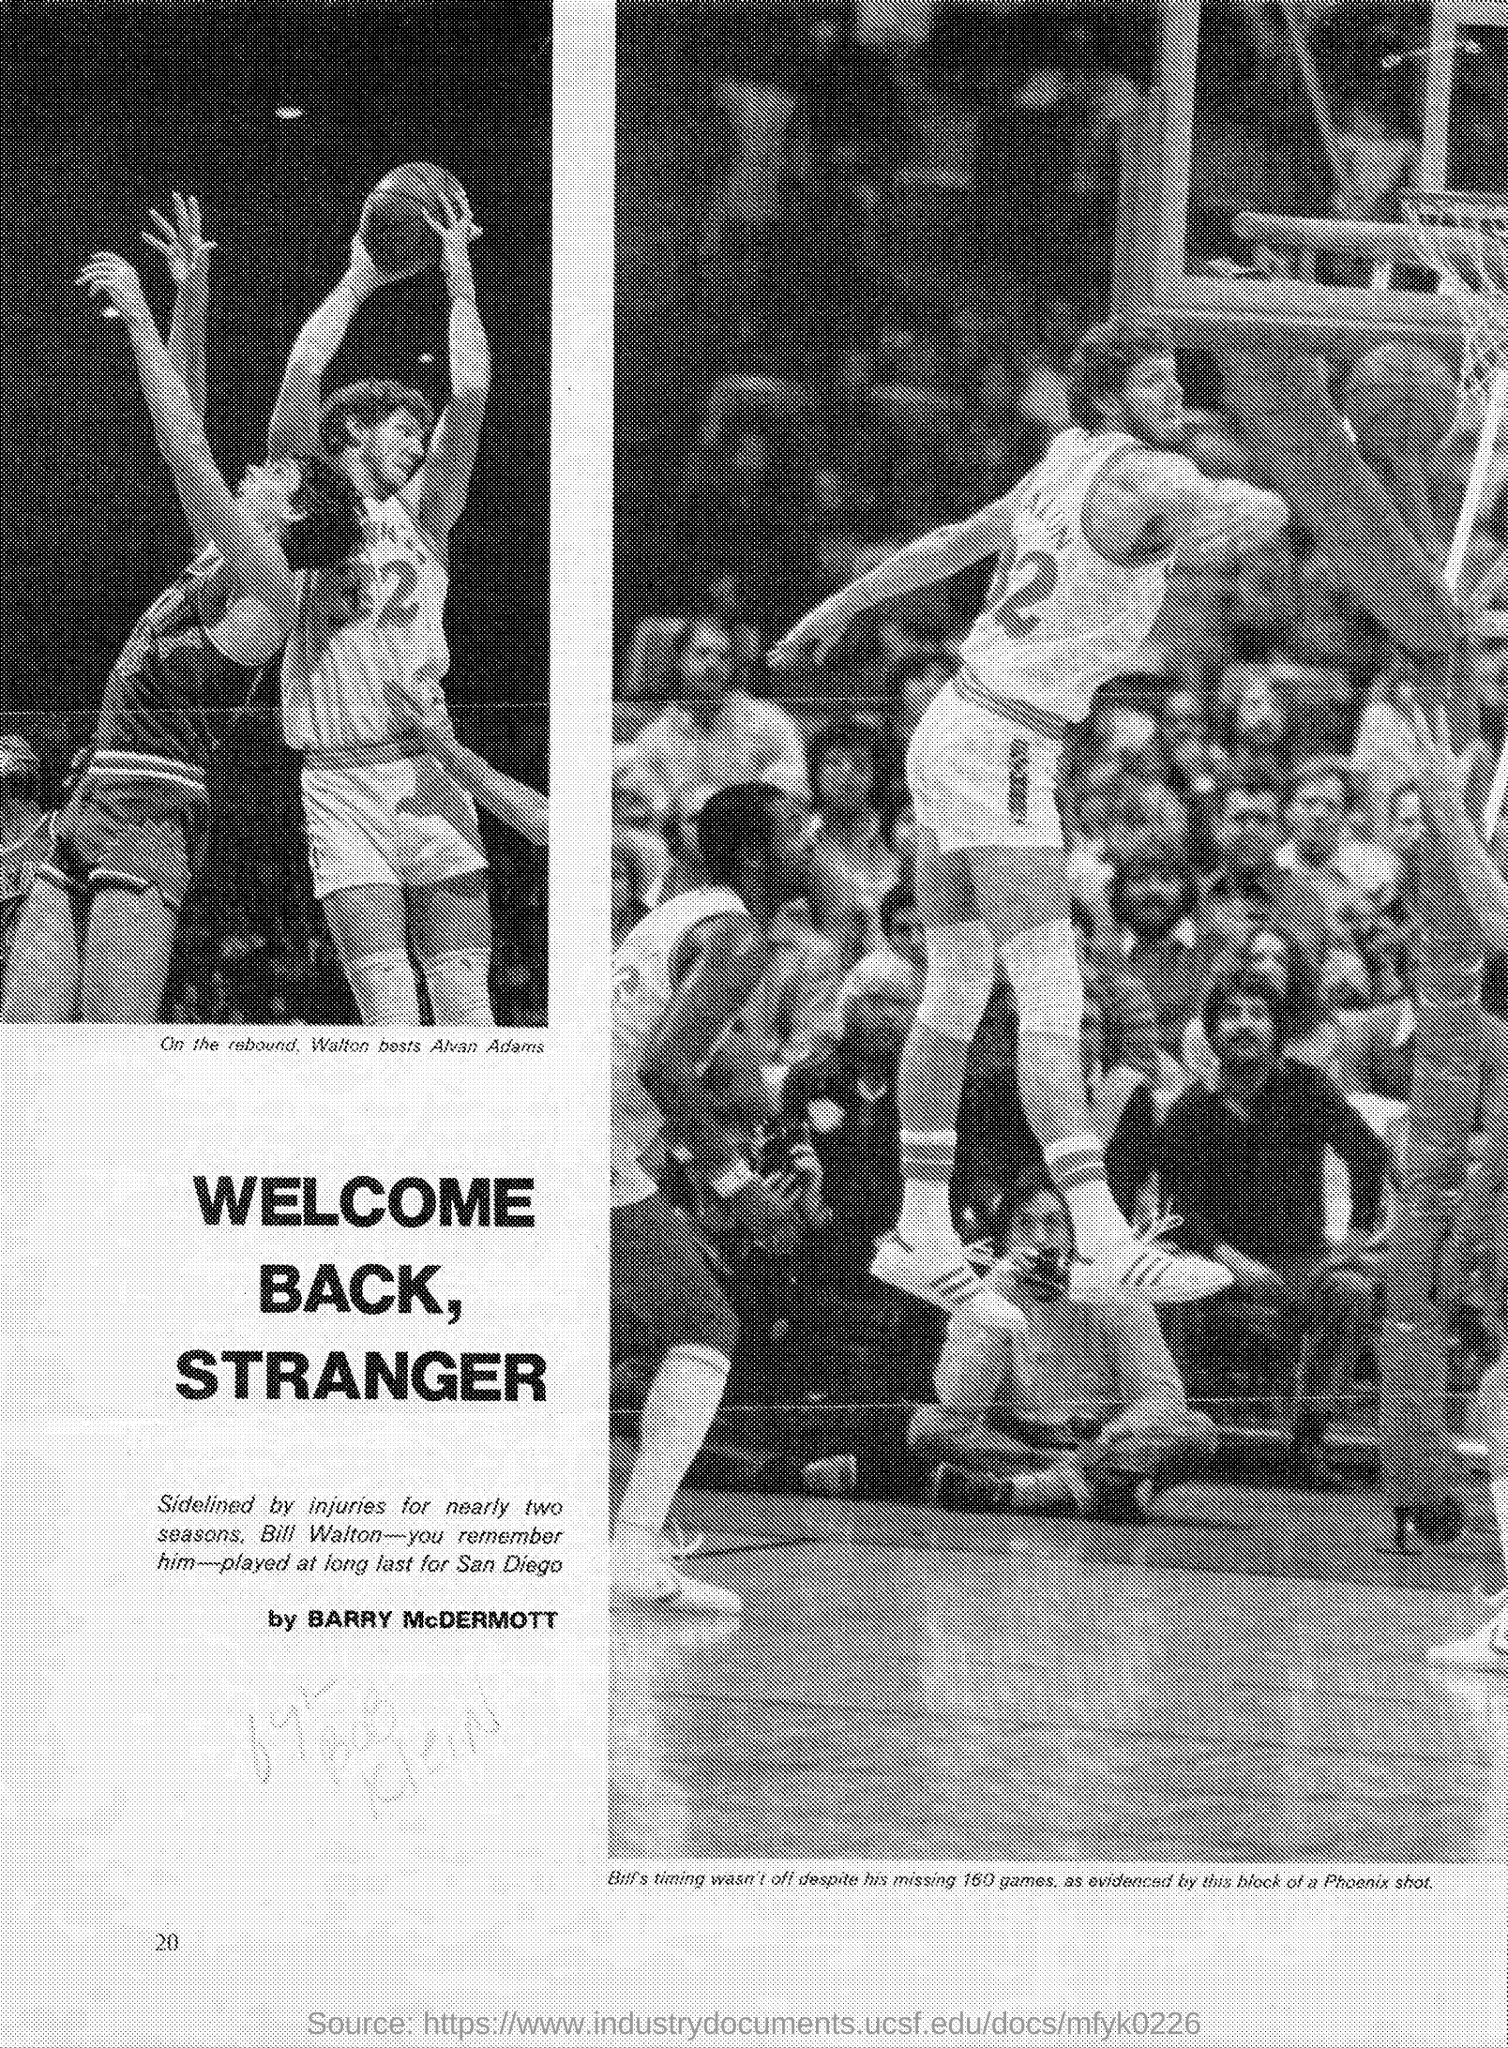Who was sidelined by injuries?
Make the answer very short. Bill Walton. Which team was bill playing for?
Ensure brevity in your answer.  San Diego. Who wrote  this?
Make the answer very short. Barry McDermott. 